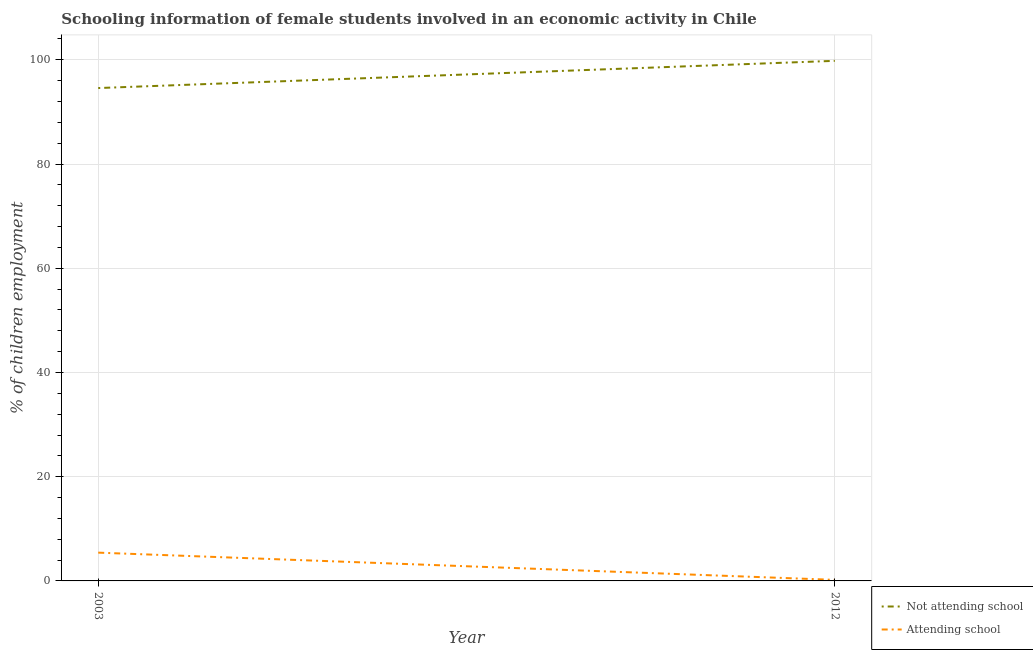How many different coloured lines are there?
Offer a very short reply. 2. Does the line corresponding to percentage of employed females who are attending school intersect with the line corresponding to percentage of employed females who are not attending school?
Make the answer very short. No. What is the percentage of employed females who are attending school in 2003?
Provide a short and direct response. 5.43. Across all years, what is the maximum percentage of employed females who are not attending school?
Your answer should be very brief. 99.8. In which year was the percentage of employed females who are not attending school maximum?
Your answer should be compact. 2012. What is the total percentage of employed females who are attending school in the graph?
Offer a very short reply. 5.63. What is the difference between the percentage of employed females who are attending school in 2003 and that in 2012?
Your response must be concise. 5.23. What is the difference between the percentage of employed females who are attending school in 2012 and the percentage of employed females who are not attending school in 2003?
Your answer should be very brief. -94.37. What is the average percentage of employed females who are not attending school per year?
Keep it short and to the point. 97.19. In the year 2003, what is the difference between the percentage of employed females who are attending school and percentage of employed females who are not attending school?
Keep it short and to the point. -89.15. What is the ratio of the percentage of employed females who are attending school in 2003 to that in 2012?
Provide a succinct answer. 27.13. Is the percentage of employed females who are attending school in 2003 less than that in 2012?
Keep it short and to the point. No. How many years are there in the graph?
Offer a very short reply. 2. Are the values on the major ticks of Y-axis written in scientific E-notation?
Your answer should be very brief. No. Does the graph contain any zero values?
Keep it short and to the point. No. How many legend labels are there?
Give a very brief answer. 2. What is the title of the graph?
Provide a short and direct response. Schooling information of female students involved in an economic activity in Chile. What is the label or title of the Y-axis?
Provide a short and direct response. % of children employment. What is the % of children employment of Not attending school in 2003?
Your response must be concise. 94.57. What is the % of children employment in Attending school in 2003?
Your response must be concise. 5.43. What is the % of children employment of Not attending school in 2012?
Offer a very short reply. 99.8. What is the % of children employment in Attending school in 2012?
Offer a terse response. 0.2. Across all years, what is the maximum % of children employment of Not attending school?
Offer a terse response. 99.8. Across all years, what is the maximum % of children employment in Attending school?
Offer a terse response. 5.43. Across all years, what is the minimum % of children employment of Not attending school?
Make the answer very short. 94.57. What is the total % of children employment of Not attending school in the graph?
Give a very brief answer. 194.37. What is the total % of children employment in Attending school in the graph?
Your answer should be very brief. 5.63. What is the difference between the % of children employment in Not attending school in 2003 and that in 2012?
Your answer should be very brief. -5.23. What is the difference between the % of children employment in Attending school in 2003 and that in 2012?
Offer a terse response. 5.23. What is the difference between the % of children employment of Not attending school in 2003 and the % of children employment of Attending school in 2012?
Offer a very short reply. 94.37. What is the average % of children employment of Not attending school per year?
Give a very brief answer. 97.19. What is the average % of children employment of Attending school per year?
Ensure brevity in your answer.  2.81. In the year 2003, what is the difference between the % of children employment in Not attending school and % of children employment in Attending school?
Your answer should be compact. 89.15. In the year 2012, what is the difference between the % of children employment of Not attending school and % of children employment of Attending school?
Offer a terse response. 99.6. What is the ratio of the % of children employment in Not attending school in 2003 to that in 2012?
Provide a short and direct response. 0.95. What is the ratio of the % of children employment of Attending school in 2003 to that in 2012?
Make the answer very short. 27.13. What is the difference between the highest and the second highest % of children employment in Not attending school?
Provide a succinct answer. 5.23. What is the difference between the highest and the second highest % of children employment of Attending school?
Your response must be concise. 5.23. What is the difference between the highest and the lowest % of children employment in Not attending school?
Ensure brevity in your answer.  5.23. What is the difference between the highest and the lowest % of children employment in Attending school?
Offer a very short reply. 5.23. 